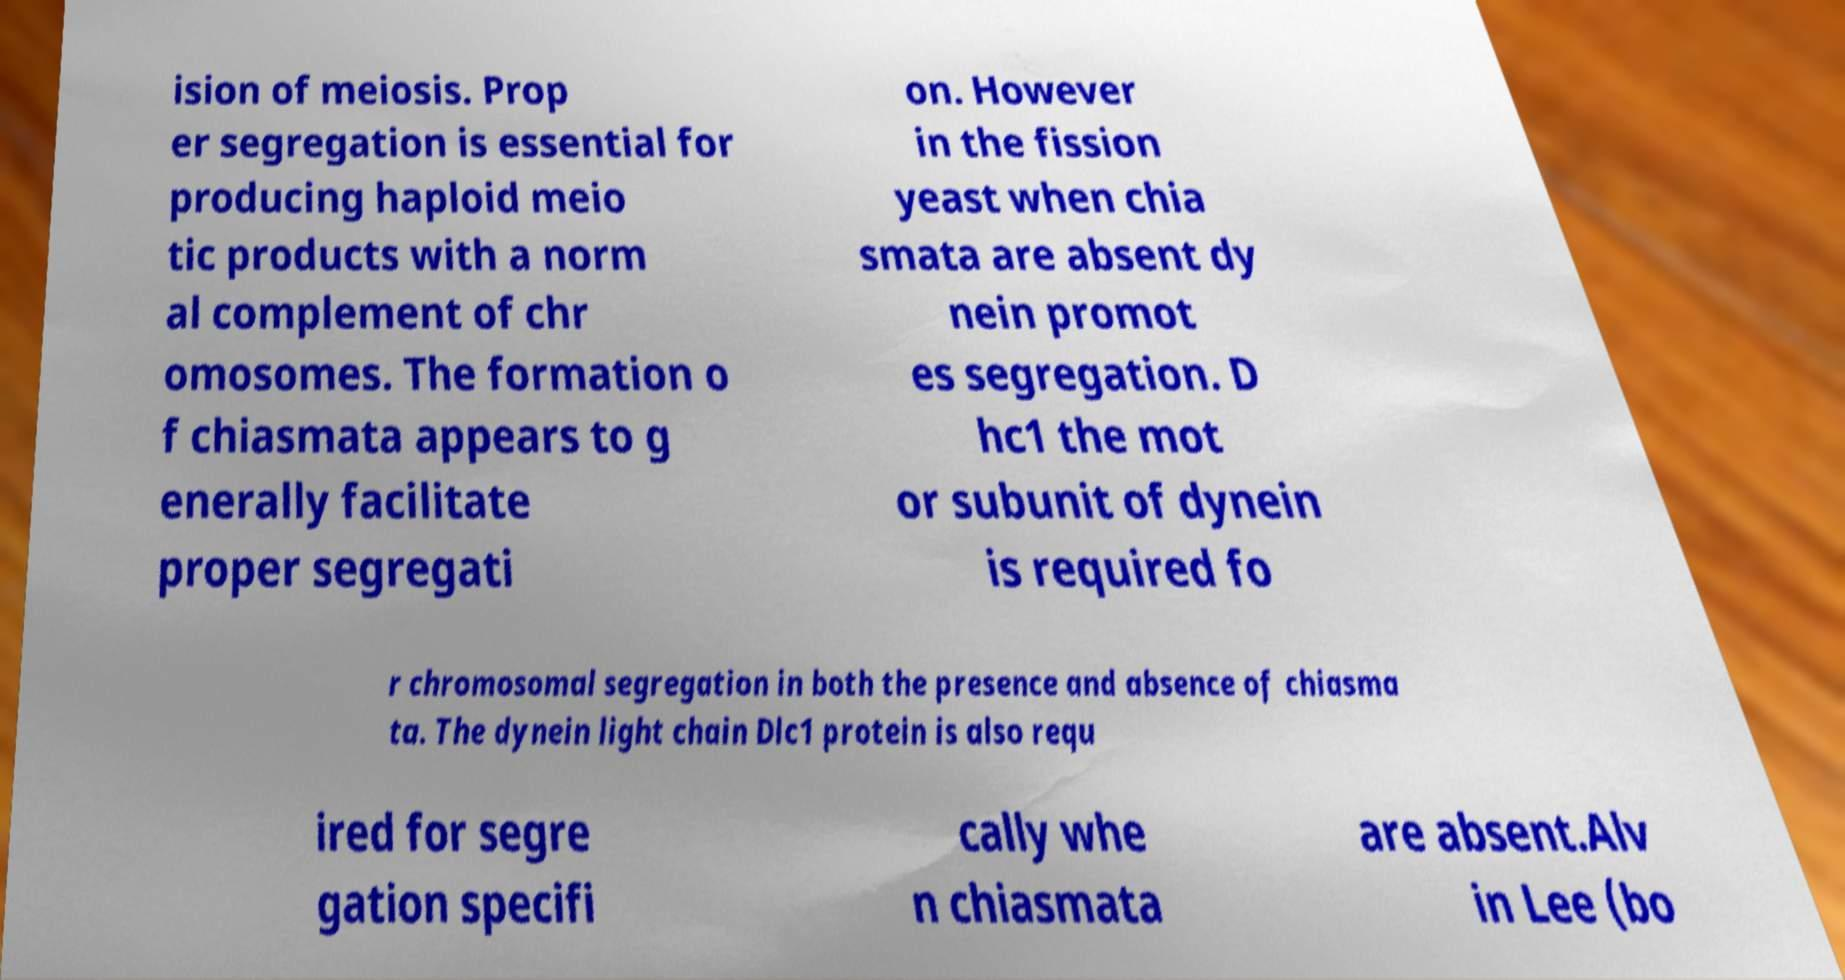Could you assist in decoding the text presented in this image and type it out clearly? ision of meiosis. Prop er segregation is essential for producing haploid meio tic products with a norm al complement of chr omosomes. The formation o f chiasmata appears to g enerally facilitate proper segregati on. However in the fission yeast when chia smata are absent dy nein promot es segregation. D hc1 the mot or subunit of dynein is required fo r chromosomal segregation in both the presence and absence of chiasma ta. The dynein light chain Dlc1 protein is also requ ired for segre gation specifi cally whe n chiasmata are absent.Alv in Lee (bo 